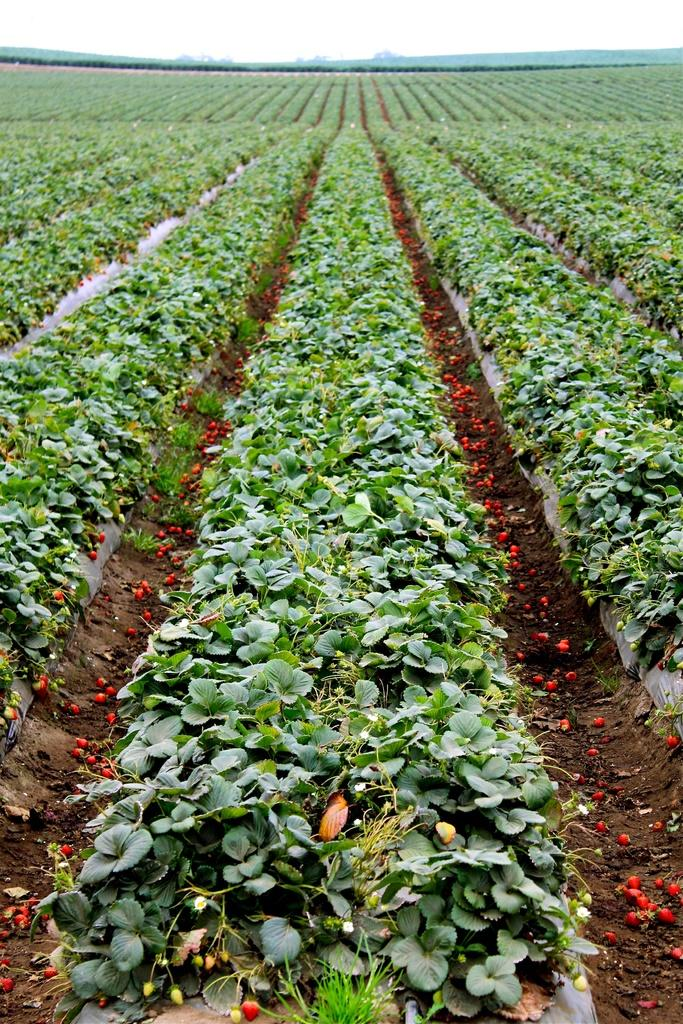What type of plants can be seen in the image? There are plants with fruits in the image. What is the condition of the fruits in the image? Some fruits are on the ground in the image. What can be seen in the distance in the image? There are mountains visible in the background of the image. What else is visible in the background of the image? The sky is visible in the background of the image. Where is the library located in the image? There is no library present in the image. What type of boats can be seen in the image? There are no boats present in the image. 